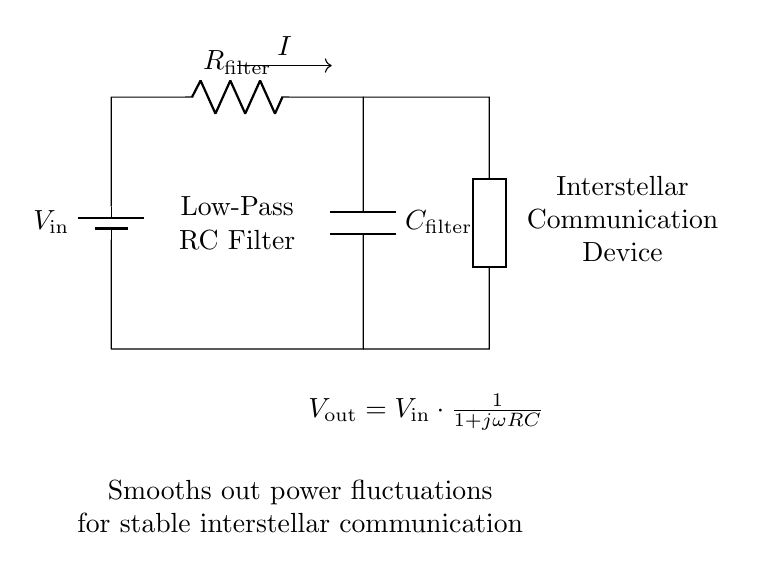What is the type of filter in this circuit? The circuit is an RC low-pass filter, which is indicated by the presence of a resistor and capacitor in the arrangement. This configuration is specifically designed to allow low frequencies to pass and attenuate high frequencies.
Answer: RC low-pass filter What components are present in the circuit? The components present are a battery, a resistor, and a capacitor, along with an interstellar communication device. The battery provides input voltage while the resistor and capacitor form the filtering section.
Answer: Battery, resistor, capacitor What does the output voltage formula represent in this circuit? The output voltage formula shows how the voltage at the output (V_out) is a function of the input voltage (V_in) and depends on frequency, resistance, and capacitance. This relationship signifies the filtering action of the circuit.
Answer: V_out = V_in * (1 / (1 + jωRC)) What is the purpose of the RC low-pass filter in this circuit? The purpose of the RC low-pass filter is to smooth out power fluctuations to ensure stable operation of the interstellar communication device. It filters out high-frequency noise, providing a cleaner power supply to the device.
Answer: Smooths out power fluctuations What is represented by the term "I" in the circuit? The term "I" represents the current flowing through the circuit, particularly through the resistor and capacitor. It indicates the rate of flow of electric charge, which is essential for the functioning of the filter.
Answer: Current What does the term "generic" denote in the circuit diagram? The term "generic" denotes the interstellar communication device, which is represented as a placeholder in the diagram. It indicates that the output of the filter is connected to a device that requires stable power input for communication functions.
Answer: Interstellar communication device 